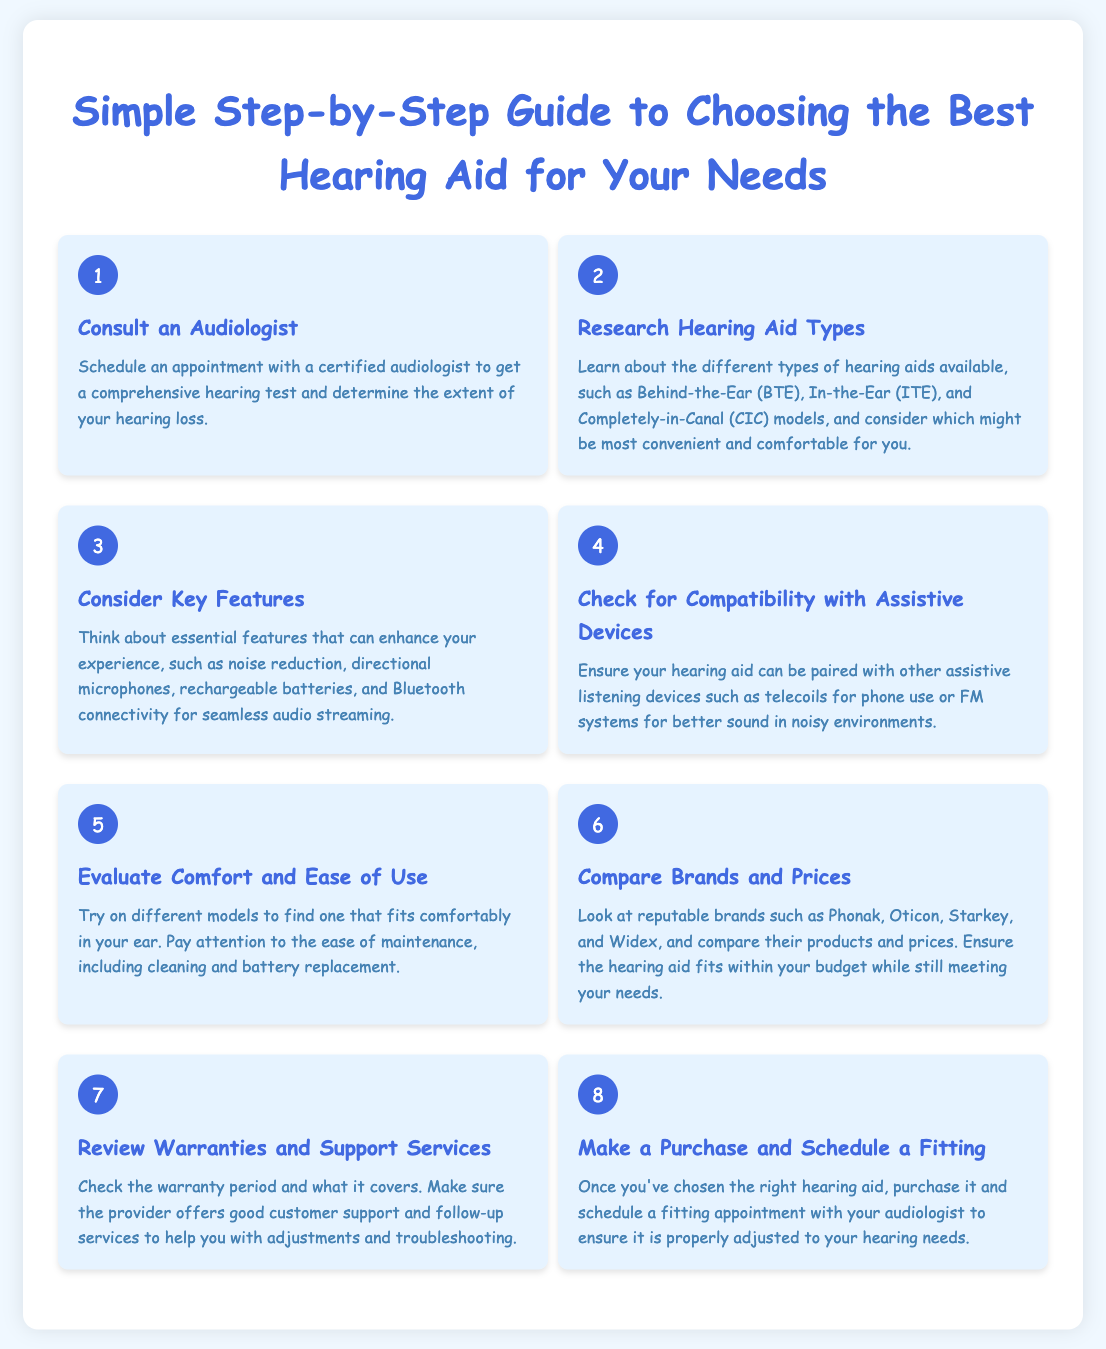What is the first step in choosing a hearing aid? The first step is to consult an audiologist to get a comprehensive hearing test.
Answer: Consult an Audiologist How many types of hearing aids are mentioned? The document lists three types of hearing aids: Behind-the-Ear (BTE), In-the-Ear (ITE), and Completely-in-Canal (CIC).
Answer: Three What should you consider regarding features? You should consider essential features that enhance your experience, including noise reduction and Bluetooth connectivity.
Answer: Key Features What is one way to evaluate comfort? Try on different models to find one that fits comfortably in your ear.
Answer: Comfort Which brands are suggested for comparison? The document suggests comparing brands like Phonak, Oticon, Starkey, and Widex.
Answer: Phonak, Oticon, Starkey, Widex What is the final step after choosing a hearing aid? The final step is to make a purchase and schedule a fitting appointment with your audiologist.
Answer: Make a Purchase and Schedule a Fitting What number step is checking for compatibility with assistive devices? It is the fourth step in the guide.
Answer: Four What aspect of customer service is highlighted? The document highlights the importance of reviewing warranties and support services.
Answer: Warranties and Support Services 